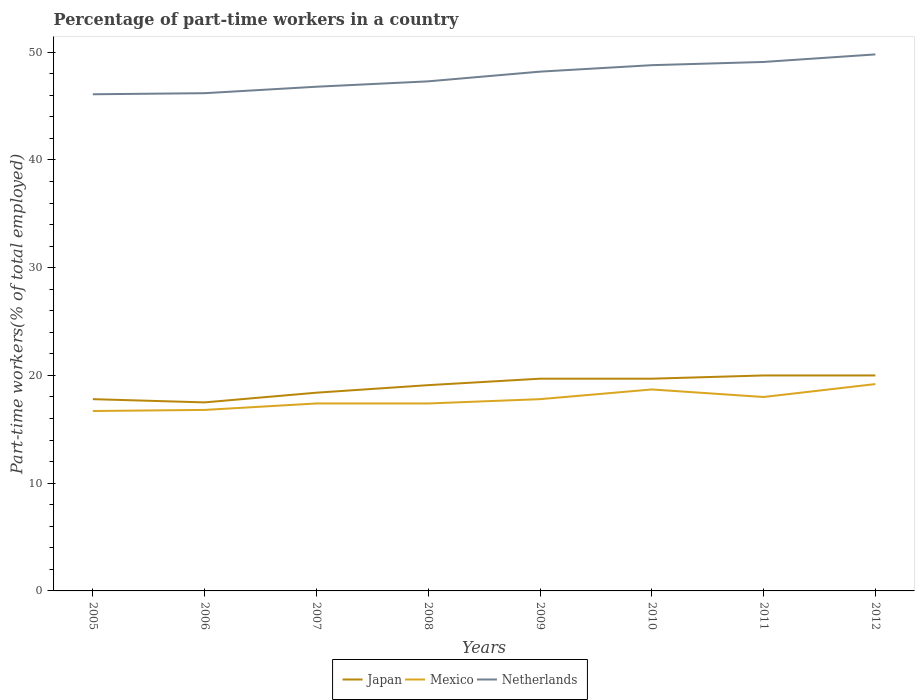Does the line corresponding to Netherlands intersect with the line corresponding to Japan?
Provide a succinct answer. No. In which year was the percentage of part-time workers in Japan maximum?
Keep it short and to the point. 2006. What is the total percentage of part-time workers in Japan in the graph?
Make the answer very short. -1.3. What is the difference between the highest and the lowest percentage of part-time workers in Japan?
Your answer should be very brief. 5. Does the graph contain any zero values?
Offer a very short reply. No. Does the graph contain grids?
Offer a terse response. No. Where does the legend appear in the graph?
Offer a terse response. Bottom center. How many legend labels are there?
Ensure brevity in your answer.  3. What is the title of the graph?
Give a very brief answer. Percentage of part-time workers in a country. What is the label or title of the Y-axis?
Your answer should be compact. Part-time workers(% of total employed). What is the Part-time workers(% of total employed) of Japan in 2005?
Your response must be concise. 17.8. What is the Part-time workers(% of total employed) in Mexico in 2005?
Your answer should be very brief. 16.7. What is the Part-time workers(% of total employed) of Netherlands in 2005?
Your response must be concise. 46.1. What is the Part-time workers(% of total employed) of Japan in 2006?
Ensure brevity in your answer.  17.5. What is the Part-time workers(% of total employed) of Mexico in 2006?
Give a very brief answer. 16.8. What is the Part-time workers(% of total employed) in Netherlands in 2006?
Provide a short and direct response. 46.2. What is the Part-time workers(% of total employed) in Japan in 2007?
Your answer should be compact. 18.4. What is the Part-time workers(% of total employed) in Mexico in 2007?
Offer a very short reply. 17.4. What is the Part-time workers(% of total employed) of Netherlands in 2007?
Keep it short and to the point. 46.8. What is the Part-time workers(% of total employed) of Japan in 2008?
Your answer should be very brief. 19.1. What is the Part-time workers(% of total employed) of Mexico in 2008?
Provide a short and direct response. 17.4. What is the Part-time workers(% of total employed) in Netherlands in 2008?
Your answer should be compact. 47.3. What is the Part-time workers(% of total employed) in Japan in 2009?
Your answer should be very brief. 19.7. What is the Part-time workers(% of total employed) of Mexico in 2009?
Your response must be concise. 17.8. What is the Part-time workers(% of total employed) of Netherlands in 2009?
Ensure brevity in your answer.  48.2. What is the Part-time workers(% of total employed) in Japan in 2010?
Your answer should be compact. 19.7. What is the Part-time workers(% of total employed) of Mexico in 2010?
Your response must be concise. 18.7. What is the Part-time workers(% of total employed) of Netherlands in 2010?
Your answer should be compact. 48.8. What is the Part-time workers(% of total employed) in Mexico in 2011?
Your response must be concise. 18. What is the Part-time workers(% of total employed) in Netherlands in 2011?
Provide a short and direct response. 49.1. What is the Part-time workers(% of total employed) of Mexico in 2012?
Provide a succinct answer. 19.2. What is the Part-time workers(% of total employed) of Netherlands in 2012?
Give a very brief answer. 49.8. Across all years, what is the maximum Part-time workers(% of total employed) in Japan?
Make the answer very short. 20. Across all years, what is the maximum Part-time workers(% of total employed) in Mexico?
Your response must be concise. 19.2. Across all years, what is the maximum Part-time workers(% of total employed) of Netherlands?
Ensure brevity in your answer.  49.8. Across all years, what is the minimum Part-time workers(% of total employed) of Mexico?
Offer a terse response. 16.7. Across all years, what is the minimum Part-time workers(% of total employed) of Netherlands?
Give a very brief answer. 46.1. What is the total Part-time workers(% of total employed) in Japan in the graph?
Make the answer very short. 152.2. What is the total Part-time workers(% of total employed) in Mexico in the graph?
Your response must be concise. 142. What is the total Part-time workers(% of total employed) of Netherlands in the graph?
Make the answer very short. 382.3. What is the difference between the Part-time workers(% of total employed) in Japan in 2005 and that in 2006?
Ensure brevity in your answer.  0.3. What is the difference between the Part-time workers(% of total employed) in Mexico in 2005 and that in 2007?
Ensure brevity in your answer.  -0.7. What is the difference between the Part-time workers(% of total employed) of Netherlands in 2005 and that in 2007?
Your answer should be compact. -0.7. What is the difference between the Part-time workers(% of total employed) in Mexico in 2005 and that in 2008?
Give a very brief answer. -0.7. What is the difference between the Part-time workers(% of total employed) of Netherlands in 2005 and that in 2008?
Offer a very short reply. -1.2. What is the difference between the Part-time workers(% of total employed) of Netherlands in 2005 and that in 2009?
Your answer should be very brief. -2.1. What is the difference between the Part-time workers(% of total employed) of Japan in 2005 and that in 2011?
Your answer should be very brief. -2.2. What is the difference between the Part-time workers(% of total employed) of Mexico in 2005 and that in 2011?
Offer a very short reply. -1.3. What is the difference between the Part-time workers(% of total employed) of Japan in 2005 and that in 2012?
Give a very brief answer. -2.2. What is the difference between the Part-time workers(% of total employed) in Mexico in 2005 and that in 2012?
Your response must be concise. -2.5. What is the difference between the Part-time workers(% of total employed) in Netherlands in 2005 and that in 2012?
Give a very brief answer. -3.7. What is the difference between the Part-time workers(% of total employed) in Mexico in 2006 and that in 2007?
Keep it short and to the point. -0.6. What is the difference between the Part-time workers(% of total employed) in Mexico in 2006 and that in 2008?
Provide a succinct answer. -0.6. What is the difference between the Part-time workers(% of total employed) in Netherlands in 2006 and that in 2008?
Offer a terse response. -1.1. What is the difference between the Part-time workers(% of total employed) in Netherlands in 2006 and that in 2009?
Offer a terse response. -2. What is the difference between the Part-time workers(% of total employed) in Japan in 2006 and that in 2010?
Your answer should be very brief. -2.2. What is the difference between the Part-time workers(% of total employed) of Mexico in 2006 and that in 2011?
Offer a terse response. -1.2. What is the difference between the Part-time workers(% of total employed) in Netherlands in 2006 and that in 2011?
Your answer should be very brief. -2.9. What is the difference between the Part-time workers(% of total employed) in Mexico in 2006 and that in 2012?
Ensure brevity in your answer.  -2.4. What is the difference between the Part-time workers(% of total employed) of Netherlands in 2006 and that in 2012?
Make the answer very short. -3.6. What is the difference between the Part-time workers(% of total employed) in Japan in 2007 and that in 2008?
Make the answer very short. -0.7. What is the difference between the Part-time workers(% of total employed) in Mexico in 2007 and that in 2008?
Your answer should be compact. 0. What is the difference between the Part-time workers(% of total employed) in Japan in 2007 and that in 2010?
Provide a succinct answer. -1.3. What is the difference between the Part-time workers(% of total employed) of Mexico in 2007 and that in 2010?
Give a very brief answer. -1.3. What is the difference between the Part-time workers(% of total employed) in Japan in 2007 and that in 2011?
Your response must be concise. -1.6. What is the difference between the Part-time workers(% of total employed) in Mexico in 2007 and that in 2011?
Ensure brevity in your answer.  -0.6. What is the difference between the Part-time workers(% of total employed) in Mexico in 2007 and that in 2012?
Offer a terse response. -1.8. What is the difference between the Part-time workers(% of total employed) of Netherlands in 2007 and that in 2012?
Your response must be concise. -3. What is the difference between the Part-time workers(% of total employed) in Netherlands in 2008 and that in 2009?
Ensure brevity in your answer.  -0.9. What is the difference between the Part-time workers(% of total employed) of Japan in 2008 and that in 2010?
Give a very brief answer. -0.6. What is the difference between the Part-time workers(% of total employed) of Japan in 2008 and that in 2011?
Give a very brief answer. -0.9. What is the difference between the Part-time workers(% of total employed) in Mexico in 2008 and that in 2011?
Provide a short and direct response. -0.6. What is the difference between the Part-time workers(% of total employed) of Mexico in 2008 and that in 2012?
Provide a short and direct response. -1.8. What is the difference between the Part-time workers(% of total employed) in Netherlands in 2008 and that in 2012?
Offer a very short reply. -2.5. What is the difference between the Part-time workers(% of total employed) in Japan in 2009 and that in 2010?
Your response must be concise. 0. What is the difference between the Part-time workers(% of total employed) of Mexico in 2009 and that in 2010?
Offer a very short reply. -0.9. What is the difference between the Part-time workers(% of total employed) of Japan in 2009 and that in 2011?
Ensure brevity in your answer.  -0.3. What is the difference between the Part-time workers(% of total employed) in Mexico in 2010 and that in 2011?
Your answer should be compact. 0.7. What is the difference between the Part-time workers(% of total employed) of Japan in 2011 and that in 2012?
Ensure brevity in your answer.  0. What is the difference between the Part-time workers(% of total employed) of Japan in 2005 and the Part-time workers(% of total employed) of Netherlands in 2006?
Keep it short and to the point. -28.4. What is the difference between the Part-time workers(% of total employed) in Mexico in 2005 and the Part-time workers(% of total employed) in Netherlands in 2006?
Make the answer very short. -29.5. What is the difference between the Part-time workers(% of total employed) of Japan in 2005 and the Part-time workers(% of total employed) of Netherlands in 2007?
Give a very brief answer. -29. What is the difference between the Part-time workers(% of total employed) in Mexico in 2005 and the Part-time workers(% of total employed) in Netherlands in 2007?
Offer a terse response. -30.1. What is the difference between the Part-time workers(% of total employed) of Japan in 2005 and the Part-time workers(% of total employed) of Mexico in 2008?
Provide a short and direct response. 0.4. What is the difference between the Part-time workers(% of total employed) in Japan in 2005 and the Part-time workers(% of total employed) in Netherlands in 2008?
Offer a terse response. -29.5. What is the difference between the Part-time workers(% of total employed) in Mexico in 2005 and the Part-time workers(% of total employed) in Netherlands in 2008?
Your answer should be compact. -30.6. What is the difference between the Part-time workers(% of total employed) in Japan in 2005 and the Part-time workers(% of total employed) in Netherlands in 2009?
Keep it short and to the point. -30.4. What is the difference between the Part-time workers(% of total employed) in Mexico in 2005 and the Part-time workers(% of total employed) in Netherlands in 2009?
Keep it short and to the point. -31.5. What is the difference between the Part-time workers(% of total employed) in Japan in 2005 and the Part-time workers(% of total employed) in Netherlands in 2010?
Offer a very short reply. -31. What is the difference between the Part-time workers(% of total employed) in Mexico in 2005 and the Part-time workers(% of total employed) in Netherlands in 2010?
Provide a short and direct response. -32.1. What is the difference between the Part-time workers(% of total employed) in Japan in 2005 and the Part-time workers(% of total employed) in Netherlands in 2011?
Your answer should be compact. -31.3. What is the difference between the Part-time workers(% of total employed) of Mexico in 2005 and the Part-time workers(% of total employed) of Netherlands in 2011?
Ensure brevity in your answer.  -32.4. What is the difference between the Part-time workers(% of total employed) in Japan in 2005 and the Part-time workers(% of total employed) in Netherlands in 2012?
Your response must be concise. -32. What is the difference between the Part-time workers(% of total employed) in Mexico in 2005 and the Part-time workers(% of total employed) in Netherlands in 2012?
Ensure brevity in your answer.  -33.1. What is the difference between the Part-time workers(% of total employed) in Japan in 2006 and the Part-time workers(% of total employed) in Netherlands in 2007?
Your response must be concise. -29.3. What is the difference between the Part-time workers(% of total employed) of Mexico in 2006 and the Part-time workers(% of total employed) of Netherlands in 2007?
Keep it short and to the point. -30. What is the difference between the Part-time workers(% of total employed) of Japan in 2006 and the Part-time workers(% of total employed) of Netherlands in 2008?
Make the answer very short. -29.8. What is the difference between the Part-time workers(% of total employed) in Mexico in 2006 and the Part-time workers(% of total employed) in Netherlands in 2008?
Give a very brief answer. -30.5. What is the difference between the Part-time workers(% of total employed) in Japan in 2006 and the Part-time workers(% of total employed) in Mexico in 2009?
Your answer should be compact. -0.3. What is the difference between the Part-time workers(% of total employed) in Japan in 2006 and the Part-time workers(% of total employed) in Netherlands in 2009?
Your answer should be compact. -30.7. What is the difference between the Part-time workers(% of total employed) in Mexico in 2006 and the Part-time workers(% of total employed) in Netherlands in 2009?
Provide a short and direct response. -31.4. What is the difference between the Part-time workers(% of total employed) in Japan in 2006 and the Part-time workers(% of total employed) in Mexico in 2010?
Your answer should be very brief. -1.2. What is the difference between the Part-time workers(% of total employed) of Japan in 2006 and the Part-time workers(% of total employed) of Netherlands in 2010?
Keep it short and to the point. -31.3. What is the difference between the Part-time workers(% of total employed) of Mexico in 2006 and the Part-time workers(% of total employed) of Netherlands in 2010?
Your answer should be very brief. -32. What is the difference between the Part-time workers(% of total employed) of Japan in 2006 and the Part-time workers(% of total employed) of Netherlands in 2011?
Offer a terse response. -31.6. What is the difference between the Part-time workers(% of total employed) of Mexico in 2006 and the Part-time workers(% of total employed) of Netherlands in 2011?
Keep it short and to the point. -32.3. What is the difference between the Part-time workers(% of total employed) of Japan in 2006 and the Part-time workers(% of total employed) of Mexico in 2012?
Your answer should be compact. -1.7. What is the difference between the Part-time workers(% of total employed) of Japan in 2006 and the Part-time workers(% of total employed) of Netherlands in 2012?
Provide a succinct answer. -32.3. What is the difference between the Part-time workers(% of total employed) of Mexico in 2006 and the Part-time workers(% of total employed) of Netherlands in 2012?
Offer a very short reply. -33. What is the difference between the Part-time workers(% of total employed) of Japan in 2007 and the Part-time workers(% of total employed) of Mexico in 2008?
Provide a short and direct response. 1. What is the difference between the Part-time workers(% of total employed) in Japan in 2007 and the Part-time workers(% of total employed) in Netherlands in 2008?
Provide a succinct answer. -28.9. What is the difference between the Part-time workers(% of total employed) in Mexico in 2007 and the Part-time workers(% of total employed) in Netherlands in 2008?
Offer a very short reply. -29.9. What is the difference between the Part-time workers(% of total employed) of Japan in 2007 and the Part-time workers(% of total employed) of Mexico in 2009?
Your response must be concise. 0.6. What is the difference between the Part-time workers(% of total employed) of Japan in 2007 and the Part-time workers(% of total employed) of Netherlands in 2009?
Offer a very short reply. -29.8. What is the difference between the Part-time workers(% of total employed) in Mexico in 2007 and the Part-time workers(% of total employed) in Netherlands in 2009?
Keep it short and to the point. -30.8. What is the difference between the Part-time workers(% of total employed) in Japan in 2007 and the Part-time workers(% of total employed) in Netherlands in 2010?
Keep it short and to the point. -30.4. What is the difference between the Part-time workers(% of total employed) of Mexico in 2007 and the Part-time workers(% of total employed) of Netherlands in 2010?
Ensure brevity in your answer.  -31.4. What is the difference between the Part-time workers(% of total employed) in Japan in 2007 and the Part-time workers(% of total employed) in Netherlands in 2011?
Offer a terse response. -30.7. What is the difference between the Part-time workers(% of total employed) in Mexico in 2007 and the Part-time workers(% of total employed) in Netherlands in 2011?
Your answer should be compact. -31.7. What is the difference between the Part-time workers(% of total employed) of Japan in 2007 and the Part-time workers(% of total employed) of Netherlands in 2012?
Offer a terse response. -31.4. What is the difference between the Part-time workers(% of total employed) in Mexico in 2007 and the Part-time workers(% of total employed) in Netherlands in 2012?
Your answer should be compact. -32.4. What is the difference between the Part-time workers(% of total employed) in Japan in 2008 and the Part-time workers(% of total employed) in Mexico in 2009?
Provide a short and direct response. 1.3. What is the difference between the Part-time workers(% of total employed) in Japan in 2008 and the Part-time workers(% of total employed) in Netherlands in 2009?
Your answer should be compact. -29.1. What is the difference between the Part-time workers(% of total employed) in Mexico in 2008 and the Part-time workers(% of total employed) in Netherlands in 2009?
Your answer should be compact. -30.8. What is the difference between the Part-time workers(% of total employed) of Japan in 2008 and the Part-time workers(% of total employed) of Mexico in 2010?
Offer a very short reply. 0.4. What is the difference between the Part-time workers(% of total employed) of Japan in 2008 and the Part-time workers(% of total employed) of Netherlands in 2010?
Give a very brief answer. -29.7. What is the difference between the Part-time workers(% of total employed) in Mexico in 2008 and the Part-time workers(% of total employed) in Netherlands in 2010?
Ensure brevity in your answer.  -31.4. What is the difference between the Part-time workers(% of total employed) in Japan in 2008 and the Part-time workers(% of total employed) in Mexico in 2011?
Keep it short and to the point. 1.1. What is the difference between the Part-time workers(% of total employed) of Mexico in 2008 and the Part-time workers(% of total employed) of Netherlands in 2011?
Give a very brief answer. -31.7. What is the difference between the Part-time workers(% of total employed) in Japan in 2008 and the Part-time workers(% of total employed) in Netherlands in 2012?
Offer a terse response. -30.7. What is the difference between the Part-time workers(% of total employed) in Mexico in 2008 and the Part-time workers(% of total employed) in Netherlands in 2012?
Make the answer very short. -32.4. What is the difference between the Part-time workers(% of total employed) in Japan in 2009 and the Part-time workers(% of total employed) in Netherlands in 2010?
Keep it short and to the point. -29.1. What is the difference between the Part-time workers(% of total employed) in Mexico in 2009 and the Part-time workers(% of total employed) in Netherlands in 2010?
Offer a terse response. -31. What is the difference between the Part-time workers(% of total employed) of Japan in 2009 and the Part-time workers(% of total employed) of Mexico in 2011?
Make the answer very short. 1.7. What is the difference between the Part-time workers(% of total employed) of Japan in 2009 and the Part-time workers(% of total employed) of Netherlands in 2011?
Provide a succinct answer. -29.4. What is the difference between the Part-time workers(% of total employed) in Mexico in 2009 and the Part-time workers(% of total employed) in Netherlands in 2011?
Your answer should be compact. -31.3. What is the difference between the Part-time workers(% of total employed) of Japan in 2009 and the Part-time workers(% of total employed) of Netherlands in 2012?
Provide a succinct answer. -30.1. What is the difference between the Part-time workers(% of total employed) of Mexico in 2009 and the Part-time workers(% of total employed) of Netherlands in 2012?
Give a very brief answer. -32. What is the difference between the Part-time workers(% of total employed) in Japan in 2010 and the Part-time workers(% of total employed) in Mexico in 2011?
Your answer should be compact. 1.7. What is the difference between the Part-time workers(% of total employed) of Japan in 2010 and the Part-time workers(% of total employed) of Netherlands in 2011?
Your answer should be compact. -29.4. What is the difference between the Part-time workers(% of total employed) of Mexico in 2010 and the Part-time workers(% of total employed) of Netherlands in 2011?
Provide a succinct answer. -30.4. What is the difference between the Part-time workers(% of total employed) in Japan in 2010 and the Part-time workers(% of total employed) in Mexico in 2012?
Keep it short and to the point. 0.5. What is the difference between the Part-time workers(% of total employed) in Japan in 2010 and the Part-time workers(% of total employed) in Netherlands in 2012?
Offer a terse response. -30.1. What is the difference between the Part-time workers(% of total employed) of Mexico in 2010 and the Part-time workers(% of total employed) of Netherlands in 2012?
Offer a very short reply. -31.1. What is the difference between the Part-time workers(% of total employed) of Japan in 2011 and the Part-time workers(% of total employed) of Mexico in 2012?
Keep it short and to the point. 0.8. What is the difference between the Part-time workers(% of total employed) of Japan in 2011 and the Part-time workers(% of total employed) of Netherlands in 2012?
Your response must be concise. -29.8. What is the difference between the Part-time workers(% of total employed) of Mexico in 2011 and the Part-time workers(% of total employed) of Netherlands in 2012?
Your response must be concise. -31.8. What is the average Part-time workers(% of total employed) of Japan per year?
Keep it short and to the point. 19.02. What is the average Part-time workers(% of total employed) in Mexico per year?
Give a very brief answer. 17.75. What is the average Part-time workers(% of total employed) in Netherlands per year?
Provide a short and direct response. 47.79. In the year 2005, what is the difference between the Part-time workers(% of total employed) in Japan and Part-time workers(% of total employed) in Mexico?
Offer a very short reply. 1.1. In the year 2005, what is the difference between the Part-time workers(% of total employed) in Japan and Part-time workers(% of total employed) in Netherlands?
Offer a terse response. -28.3. In the year 2005, what is the difference between the Part-time workers(% of total employed) of Mexico and Part-time workers(% of total employed) of Netherlands?
Your answer should be very brief. -29.4. In the year 2006, what is the difference between the Part-time workers(% of total employed) of Japan and Part-time workers(% of total employed) of Mexico?
Provide a succinct answer. 0.7. In the year 2006, what is the difference between the Part-time workers(% of total employed) in Japan and Part-time workers(% of total employed) in Netherlands?
Keep it short and to the point. -28.7. In the year 2006, what is the difference between the Part-time workers(% of total employed) in Mexico and Part-time workers(% of total employed) in Netherlands?
Your answer should be very brief. -29.4. In the year 2007, what is the difference between the Part-time workers(% of total employed) in Japan and Part-time workers(% of total employed) in Netherlands?
Ensure brevity in your answer.  -28.4. In the year 2007, what is the difference between the Part-time workers(% of total employed) of Mexico and Part-time workers(% of total employed) of Netherlands?
Make the answer very short. -29.4. In the year 2008, what is the difference between the Part-time workers(% of total employed) of Japan and Part-time workers(% of total employed) of Mexico?
Offer a very short reply. 1.7. In the year 2008, what is the difference between the Part-time workers(% of total employed) in Japan and Part-time workers(% of total employed) in Netherlands?
Your answer should be very brief. -28.2. In the year 2008, what is the difference between the Part-time workers(% of total employed) in Mexico and Part-time workers(% of total employed) in Netherlands?
Provide a short and direct response. -29.9. In the year 2009, what is the difference between the Part-time workers(% of total employed) of Japan and Part-time workers(% of total employed) of Mexico?
Provide a succinct answer. 1.9. In the year 2009, what is the difference between the Part-time workers(% of total employed) of Japan and Part-time workers(% of total employed) of Netherlands?
Provide a succinct answer. -28.5. In the year 2009, what is the difference between the Part-time workers(% of total employed) in Mexico and Part-time workers(% of total employed) in Netherlands?
Keep it short and to the point. -30.4. In the year 2010, what is the difference between the Part-time workers(% of total employed) in Japan and Part-time workers(% of total employed) in Netherlands?
Offer a terse response. -29.1. In the year 2010, what is the difference between the Part-time workers(% of total employed) of Mexico and Part-time workers(% of total employed) of Netherlands?
Provide a succinct answer. -30.1. In the year 2011, what is the difference between the Part-time workers(% of total employed) of Japan and Part-time workers(% of total employed) of Netherlands?
Offer a very short reply. -29.1. In the year 2011, what is the difference between the Part-time workers(% of total employed) in Mexico and Part-time workers(% of total employed) in Netherlands?
Offer a terse response. -31.1. In the year 2012, what is the difference between the Part-time workers(% of total employed) in Japan and Part-time workers(% of total employed) in Mexico?
Provide a succinct answer. 0.8. In the year 2012, what is the difference between the Part-time workers(% of total employed) of Japan and Part-time workers(% of total employed) of Netherlands?
Ensure brevity in your answer.  -29.8. In the year 2012, what is the difference between the Part-time workers(% of total employed) in Mexico and Part-time workers(% of total employed) in Netherlands?
Give a very brief answer. -30.6. What is the ratio of the Part-time workers(% of total employed) of Japan in 2005 to that in 2006?
Ensure brevity in your answer.  1.02. What is the ratio of the Part-time workers(% of total employed) in Japan in 2005 to that in 2007?
Keep it short and to the point. 0.97. What is the ratio of the Part-time workers(% of total employed) of Mexico in 2005 to that in 2007?
Make the answer very short. 0.96. What is the ratio of the Part-time workers(% of total employed) of Japan in 2005 to that in 2008?
Your answer should be very brief. 0.93. What is the ratio of the Part-time workers(% of total employed) of Mexico in 2005 to that in 2008?
Your answer should be compact. 0.96. What is the ratio of the Part-time workers(% of total employed) in Netherlands in 2005 to that in 2008?
Keep it short and to the point. 0.97. What is the ratio of the Part-time workers(% of total employed) of Japan in 2005 to that in 2009?
Offer a very short reply. 0.9. What is the ratio of the Part-time workers(% of total employed) of Mexico in 2005 to that in 2009?
Provide a succinct answer. 0.94. What is the ratio of the Part-time workers(% of total employed) in Netherlands in 2005 to that in 2009?
Your answer should be compact. 0.96. What is the ratio of the Part-time workers(% of total employed) in Japan in 2005 to that in 2010?
Keep it short and to the point. 0.9. What is the ratio of the Part-time workers(% of total employed) in Mexico in 2005 to that in 2010?
Ensure brevity in your answer.  0.89. What is the ratio of the Part-time workers(% of total employed) of Netherlands in 2005 to that in 2010?
Your answer should be very brief. 0.94. What is the ratio of the Part-time workers(% of total employed) in Japan in 2005 to that in 2011?
Ensure brevity in your answer.  0.89. What is the ratio of the Part-time workers(% of total employed) in Mexico in 2005 to that in 2011?
Give a very brief answer. 0.93. What is the ratio of the Part-time workers(% of total employed) of Netherlands in 2005 to that in 2011?
Ensure brevity in your answer.  0.94. What is the ratio of the Part-time workers(% of total employed) in Japan in 2005 to that in 2012?
Give a very brief answer. 0.89. What is the ratio of the Part-time workers(% of total employed) in Mexico in 2005 to that in 2012?
Provide a short and direct response. 0.87. What is the ratio of the Part-time workers(% of total employed) in Netherlands in 2005 to that in 2012?
Offer a terse response. 0.93. What is the ratio of the Part-time workers(% of total employed) of Japan in 2006 to that in 2007?
Provide a succinct answer. 0.95. What is the ratio of the Part-time workers(% of total employed) in Mexico in 2006 to that in 2007?
Ensure brevity in your answer.  0.97. What is the ratio of the Part-time workers(% of total employed) in Netherlands in 2006 to that in 2007?
Provide a succinct answer. 0.99. What is the ratio of the Part-time workers(% of total employed) of Japan in 2006 to that in 2008?
Offer a terse response. 0.92. What is the ratio of the Part-time workers(% of total employed) in Mexico in 2006 to that in 2008?
Ensure brevity in your answer.  0.97. What is the ratio of the Part-time workers(% of total employed) of Netherlands in 2006 to that in 2008?
Keep it short and to the point. 0.98. What is the ratio of the Part-time workers(% of total employed) in Japan in 2006 to that in 2009?
Provide a short and direct response. 0.89. What is the ratio of the Part-time workers(% of total employed) in Mexico in 2006 to that in 2009?
Ensure brevity in your answer.  0.94. What is the ratio of the Part-time workers(% of total employed) of Netherlands in 2006 to that in 2009?
Offer a terse response. 0.96. What is the ratio of the Part-time workers(% of total employed) of Japan in 2006 to that in 2010?
Offer a very short reply. 0.89. What is the ratio of the Part-time workers(% of total employed) of Mexico in 2006 to that in 2010?
Offer a very short reply. 0.9. What is the ratio of the Part-time workers(% of total employed) of Netherlands in 2006 to that in 2010?
Make the answer very short. 0.95. What is the ratio of the Part-time workers(% of total employed) of Mexico in 2006 to that in 2011?
Offer a very short reply. 0.93. What is the ratio of the Part-time workers(% of total employed) in Netherlands in 2006 to that in 2011?
Provide a short and direct response. 0.94. What is the ratio of the Part-time workers(% of total employed) in Japan in 2006 to that in 2012?
Your answer should be compact. 0.88. What is the ratio of the Part-time workers(% of total employed) in Netherlands in 2006 to that in 2012?
Ensure brevity in your answer.  0.93. What is the ratio of the Part-time workers(% of total employed) in Japan in 2007 to that in 2008?
Give a very brief answer. 0.96. What is the ratio of the Part-time workers(% of total employed) of Mexico in 2007 to that in 2008?
Provide a succinct answer. 1. What is the ratio of the Part-time workers(% of total employed) in Netherlands in 2007 to that in 2008?
Offer a terse response. 0.99. What is the ratio of the Part-time workers(% of total employed) of Japan in 2007 to that in 2009?
Your response must be concise. 0.93. What is the ratio of the Part-time workers(% of total employed) of Mexico in 2007 to that in 2009?
Your answer should be compact. 0.98. What is the ratio of the Part-time workers(% of total employed) of Netherlands in 2007 to that in 2009?
Give a very brief answer. 0.97. What is the ratio of the Part-time workers(% of total employed) of Japan in 2007 to that in 2010?
Keep it short and to the point. 0.93. What is the ratio of the Part-time workers(% of total employed) of Mexico in 2007 to that in 2010?
Your answer should be very brief. 0.93. What is the ratio of the Part-time workers(% of total employed) of Netherlands in 2007 to that in 2010?
Your answer should be compact. 0.96. What is the ratio of the Part-time workers(% of total employed) in Mexico in 2007 to that in 2011?
Provide a short and direct response. 0.97. What is the ratio of the Part-time workers(% of total employed) of Netherlands in 2007 to that in 2011?
Your answer should be very brief. 0.95. What is the ratio of the Part-time workers(% of total employed) of Mexico in 2007 to that in 2012?
Keep it short and to the point. 0.91. What is the ratio of the Part-time workers(% of total employed) in Netherlands in 2007 to that in 2012?
Your answer should be very brief. 0.94. What is the ratio of the Part-time workers(% of total employed) in Japan in 2008 to that in 2009?
Make the answer very short. 0.97. What is the ratio of the Part-time workers(% of total employed) in Mexico in 2008 to that in 2009?
Offer a very short reply. 0.98. What is the ratio of the Part-time workers(% of total employed) of Netherlands in 2008 to that in 2009?
Your answer should be compact. 0.98. What is the ratio of the Part-time workers(% of total employed) of Japan in 2008 to that in 2010?
Ensure brevity in your answer.  0.97. What is the ratio of the Part-time workers(% of total employed) in Mexico in 2008 to that in 2010?
Your response must be concise. 0.93. What is the ratio of the Part-time workers(% of total employed) of Netherlands in 2008 to that in 2010?
Offer a very short reply. 0.97. What is the ratio of the Part-time workers(% of total employed) of Japan in 2008 to that in 2011?
Provide a succinct answer. 0.95. What is the ratio of the Part-time workers(% of total employed) in Mexico in 2008 to that in 2011?
Ensure brevity in your answer.  0.97. What is the ratio of the Part-time workers(% of total employed) of Netherlands in 2008 to that in 2011?
Offer a terse response. 0.96. What is the ratio of the Part-time workers(% of total employed) of Japan in 2008 to that in 2012?
Your answer should be compact. 0.95. What is the ratio of the Part-time workers(% of total employed) of Mexico in 2008 to that in 2012?
Your answer should be compact. 0.91. What is the ratio of the Part-time workers(% of total employed) of Netherlands in 2008 to that in 2012?
Provide a succinct answer. 0.95. What is the ratio of the Part-time workers(% of total employed) of Mexico in 2009 to that in 2010?
Your answer should be compact. 0.95. What is the ratio of the Part-time workers(% of total employed) of Japan in 2009 to that in 2011?
Offer a terse response. 0.98. What is the ratio of the Part-time workers(% of total employed) of Mexico in 2009 to that in 2011?
Offer a terse response. 0.99. What is the ratio of the Part-time workers(% of total employed) in Netherlands in 2009 to that in 2011?
Your answer should be compact. 0.98. What is the ratio of the Part-time workers(% of total employed) of Mexico in 2009 to that in 2012?
Make the answer very short. 0.93. What is the ratio of the Part-time workers(% of total employed) in Netherlands in 2009 to that in 2012?
Keep it short and to the point. 0.97. What is the ratio of the Part-time workers(% of total employed) in Mexico in 2010 to that in 2011?
Your response must be concise. 1.04. What is the ratio of the Part-time workers(% of total employed) of Japan in 2010 to that in 2012?
Keep it short and to the point. 0.98. What is the ratio of the Part-time workers(% of total employed) of Mexico in 2010 to that in 2012?
Offer a very short reply. 0.97. What is the ratio of the Part-time workers(% of total employed) of Netherlands in 2010 to that in 2012?
Offer a very short reply. 0.98. What is the ratio of the Part-time workers(% of total employed) in Japan in 2011 to that in 2012?
Offer a very short reply. 1. What is the ratio of the Part-time workers(% of total employed) in Mexico in 2011 to that in 2012?
Provide a short and direct response. 0.94. What is the ratio of the Part-time workers(% of total employed) in Netherlands in 2011 to that in 2012?
Make the answer very short. 0.99. What is the difference between the highest and the second highest Part-time workers(% of total employed) in Mexico?
Provide a succinct answer. 0.5. What is the difference between the highest and the second highest Part-time workers(% of total employed) of Netherlands?
Keep it short and to the point. 0.7. What is the difference between the highest and the lowest Part-time workers(% of total employed) of Mexico?
Provide a succinct answer. 2.5. What is the difference between the highest and the lowest Part-time workers(% of total employed) in Netherlands?
Provide a short and direct response. 3.7. 